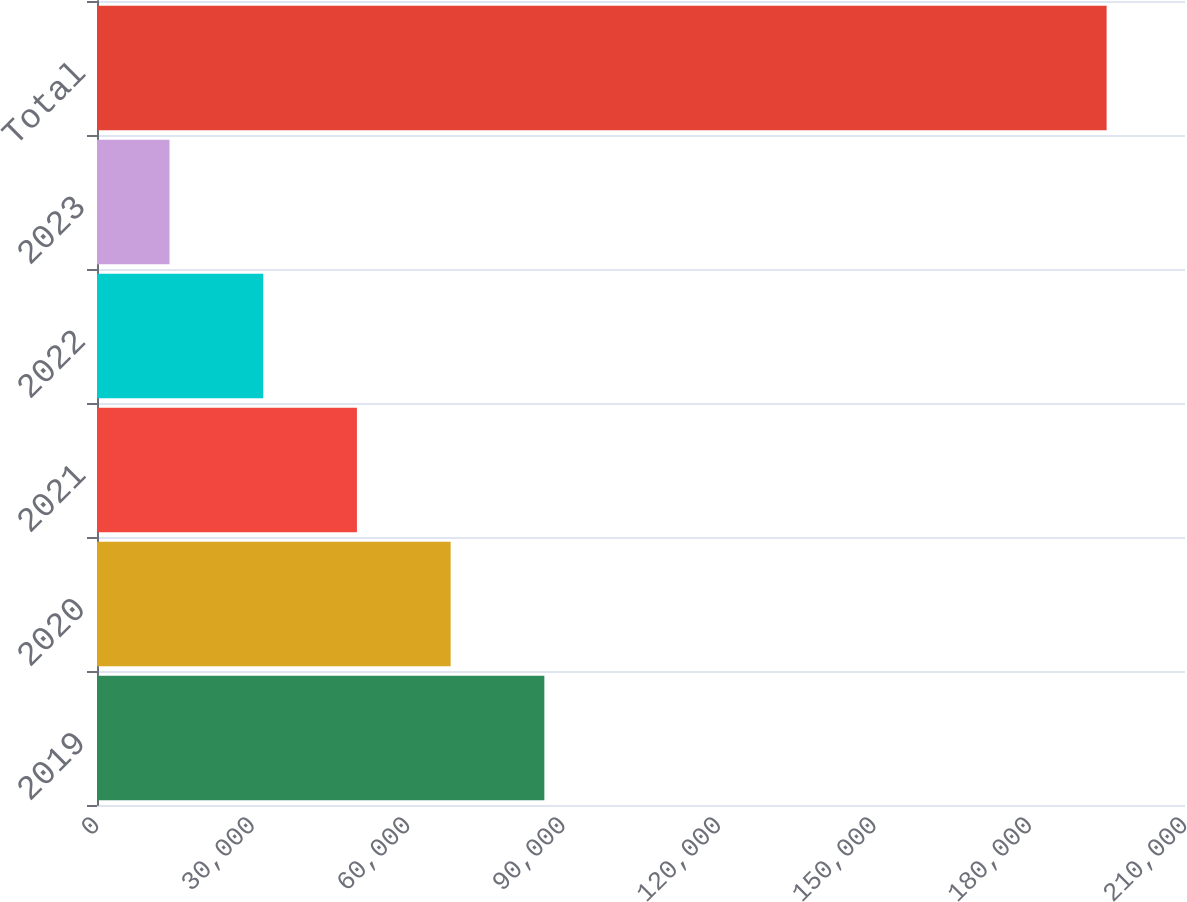Convert chart to OTSL. <chart><loc_0><loc_0><loc_500><loc_500><bar_chart><fcel>2019<fcel>2020<fcel>2021<fcel>2022<fcel>2023<fcel>Total<nl><fcel>86345.6<fcel>68257.7<fcel>50169.8<fcel>32081.9<fcel>13994<fcel>194873<nl></chart> 